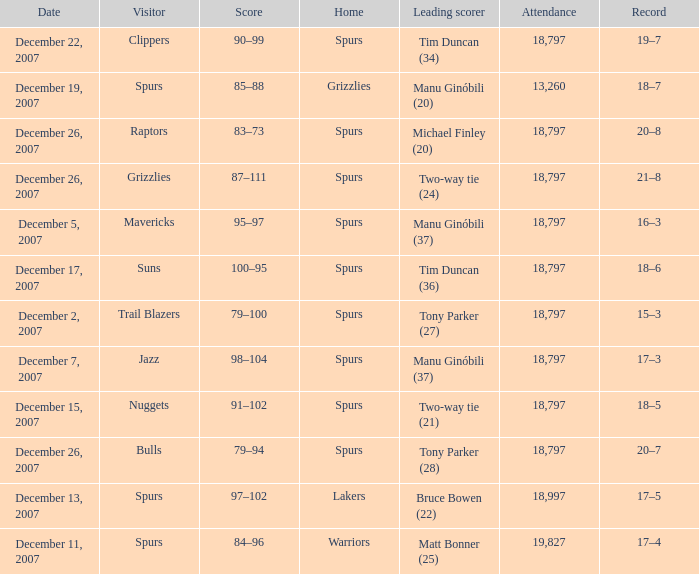What is the highest attendace of the game with the Lakers as the home team? 18997.0. 